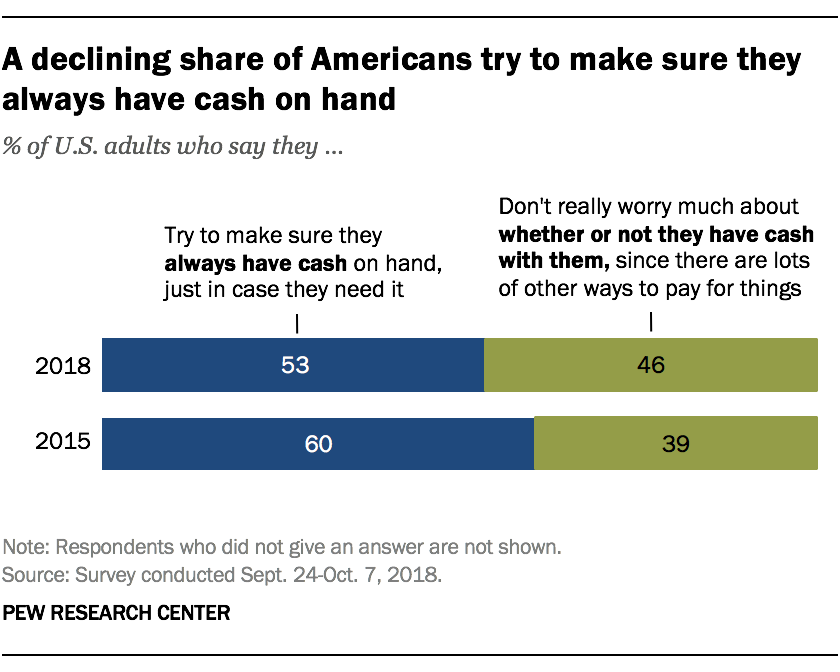Outline some significant characteristics in this image. The difference in the value of both green bars is not greater than the difference in the value of both blue bars. The color of the leftmost bar is blue. 